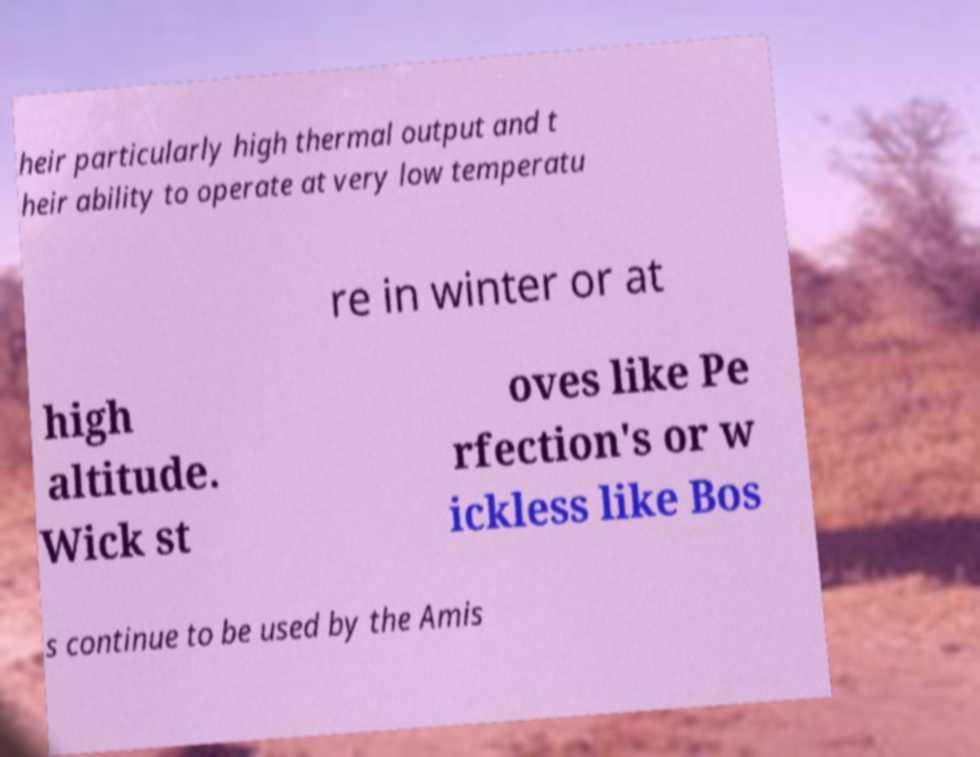For documentation purposes, I need the text within this image transcribed. Could you provide that? heir particularly high thermal output and t heir ability to operate at very low temperatu re in winter or at high altitude. Wick st oves like Pe rfection's or w ickless like Bos s continue to be used by the Amis 